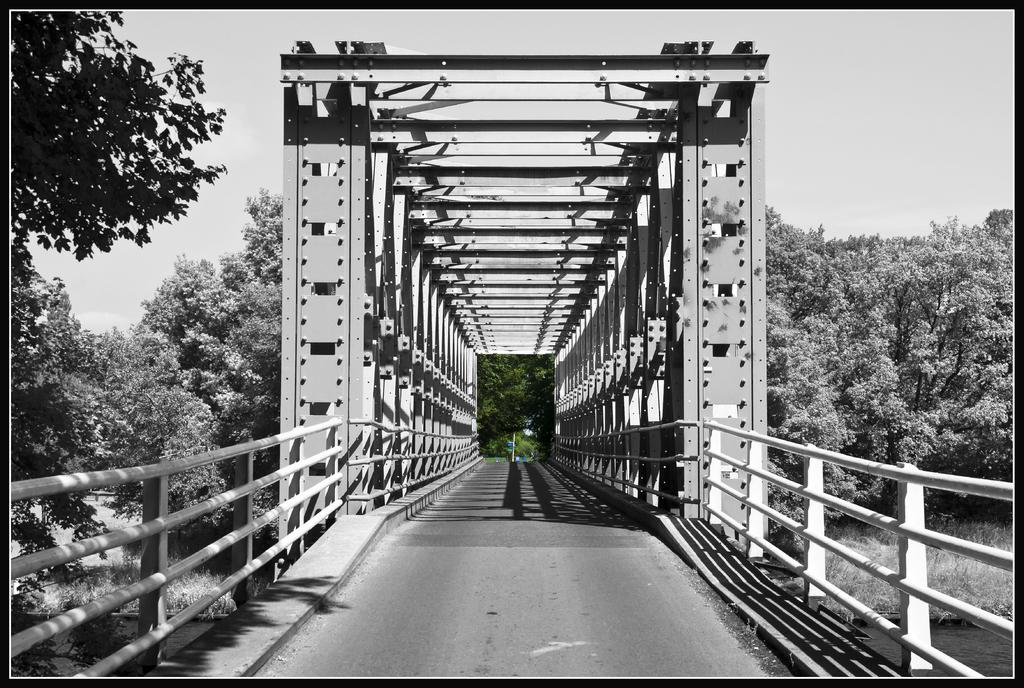What type of structure can be seen in the image? There is a bridge in the image. What type of barriers are present in the image? There are fences in the image. What type of long, thin objects can be seen in the image? There are rods in the image. What natural element is visible in the image? There is water visible in the image. What type of vegetation is present in the image? There are trees in the image. What is visible in the background of the image? The sky is visible in the background of the image. What type of hair can be seen on the bridge in the image? There is no hair present on the bridge in the image. Can you tell me how the arm is positioned on the bridge in the image? There is no arm present on the bridge in the image. 